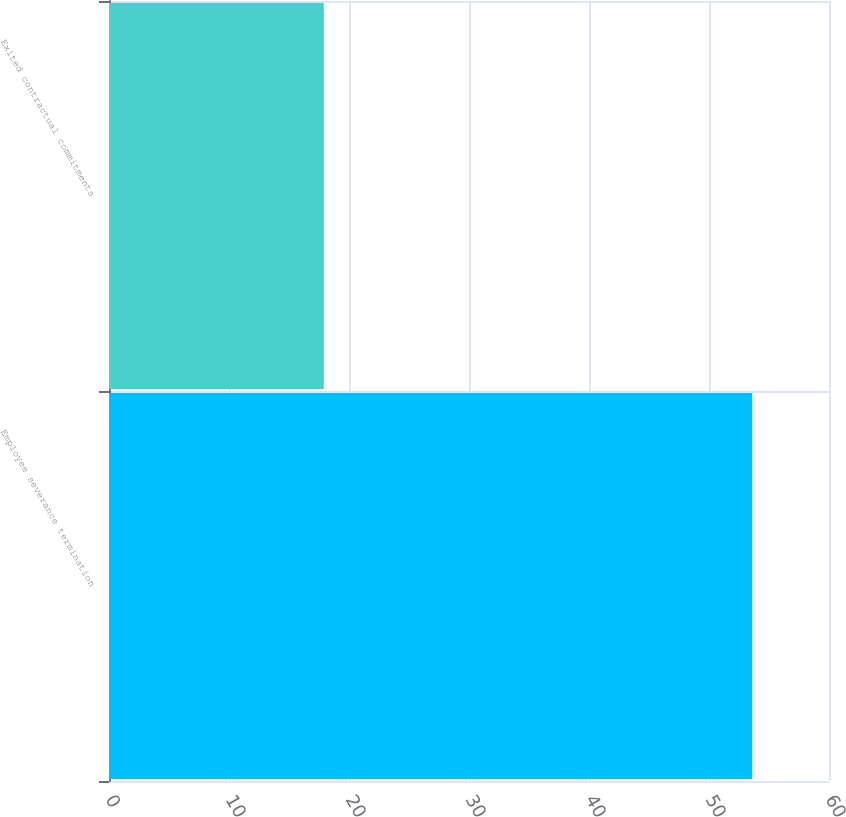Convert chart to OTSL. <chart><loc_0><loc_0><loc_500><loc_500><bar_chart><fcel>Employee severance termination<fcel>Exited contractual commitments<nl><fcel>53.6<fcel>17.9<nl></chart> 